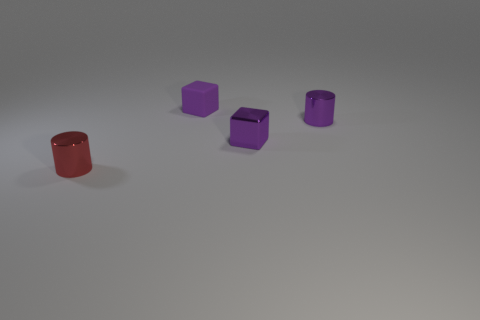Is the shape of the red shiny thing the same as the metal object behind the purple metallic cube?
Provide a short and direct response. Yes. Are there fewer purple blocks that are in front of the purple shiny cylinder than things behind the metallic block?
Ensure brevity in your answer.  Yes. There is another object that is the same shape as the small purple rubber thing; what is it made of?
Your response must be concise. Metal. Do the tiny rubber block and the metallic cube have the same color?
Keep it short and to the point. Yes. There is a small red object that is made of the same material as the purple cylinder; what shape is it?
Offer a terse response. Cylinder. How many other small metallic things have the same shape as the tiny red metallic object?
Offer a terse response. 1. What is the shape of the purple metallic thing behind the tiny purple shiny object on the left side of the purple metal cylinder?
Your response must be concise. Cylinder. What number of cyan matte cylinders are the same size as the metallic block?
Provide a succinct answer. 0. What number of metallic cubes are on the right side of the purple cube that is to the right of the small purple matte thing?
Your answer should be compact. 0. Do the small metallic cylinder to the right of the red thing and the rubber object have the same color?
Your answer should be very brief. Yes. 